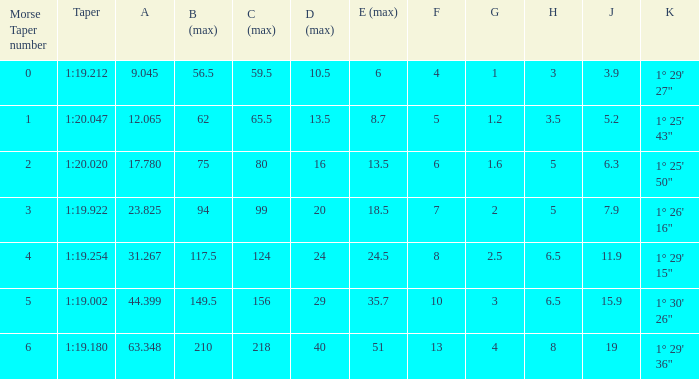Name the h when c max is 99 5.0. 